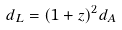<formula> <loc_0><loc_0><loc_500><loc_500>d _ { L } = ( 1 + z ) ^ { 2 } d _ { A }</formula> 